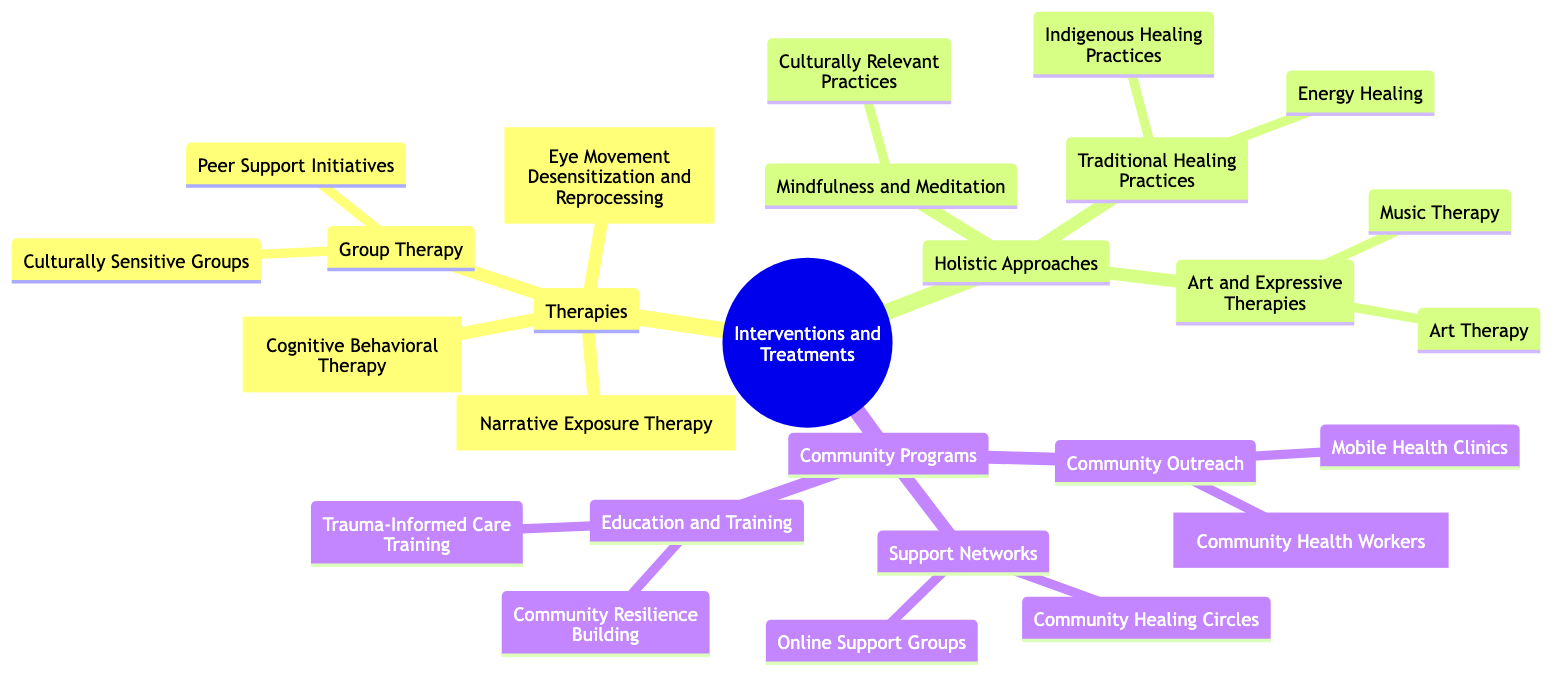What are the three main categories of interventions? The diagram lists three main categories of interventions: Therapies, Holistic Approaches, and Community Programs. Each of these categories represents a different strategic focus for treating trauma in marginalized populations.
Answer: Therapies, Holistic Approaches, Community Programs How many types of therapies are listed? In the Therapies category, there are four distinct types mentioned: Cognitive Behavioral Therapy, Eye Movement Desensitization and Reprocessing, Narrative Exposure Therapy, and Group Therapy. This includes an additional two subtypes within Group Therapy, making a total of six.
Answer: 4 What holistic approach incorporates cultural traditions? The diagram notes that Mindfulness and Meditation includes culturally relevant practices, which refer to the incorporation of cultural traditions like Native American talking circles or African drumming sessions.
Answer: Culturally Relevant Practices What community program involves mobile clinics? Under the Community Outreach category, the diagram specifies Mobile Health Clinics as a program that provides mental health services in underserved areas. This directly addresses accessibility to care.
Answer: Mobile Health Clinics Which type of therapy focuses on creating supportive environments? The Group Therapy type is centered on fostering supportive environments, as it includes Culturally Sensitive Groups and Peer Support Initiatives designed to be welcoming to members of marginalized communities.
Answer: Group Therapy What traditional healing practice includes Reiki? The diagram lists Energy Healing as a traditional healing practice that can include methods like Reiki, integrated within a culturally respectful framework. This highlights alternative healing modalities that respect cultural contexts.
Answer: Energy Healing What is the goal of Community Resilience Building? Community Resilience Building, an element of the Education and Training category, aims at workshops that focus on building resilience within the community through education and support. This implies a focus on long-term strategies for healing and support.
Answer: Workshops What is the main purpose of Community Health Workers? The Community Health Workers are deployed from within the community to build trust and deliver trauma-informed care, emphasizing the importance of community representation in healthcare delivery.
Answer: Build trust and deliver care How are online support groups described? Online Support Groups are described as digital platforms that provide tailored support networks for marginalized communities, indicating accessibility and flexibility in support mechanisms outside traditional settings.
Answer: Tailored support networks 